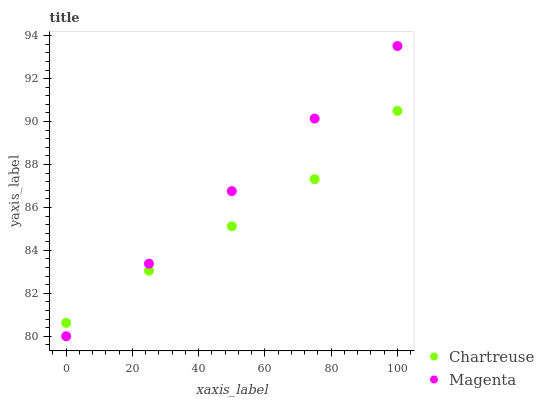Does Chartreuse have the minimum area under the curve?
Answer yes or no. Yes. Does Magenta have the maximum area under the curve?
Answer yes or no. Yes. Does Magenta have the minimum area under the curve?
Answer yes or no. No. Is Magenta the smoothest?
Answer yes or no. Yes. Is Chartreuse the roughest?
Answer yes or no. Yes. Is Magenta the roughest?
Answer yes or no. No. Does Magenta have the lowest value?
Answer yes or no. Yes. Does Magenta have the highest value?
Answer yes or no. Yes. Does Chartreuse intersect Magenta?
Answer yes or no. Yes. Is Chartreuse less than Magenta?
Answer yes or no. No. Is Chartreuse greater than Magenta?
Answer yes or no. No. 